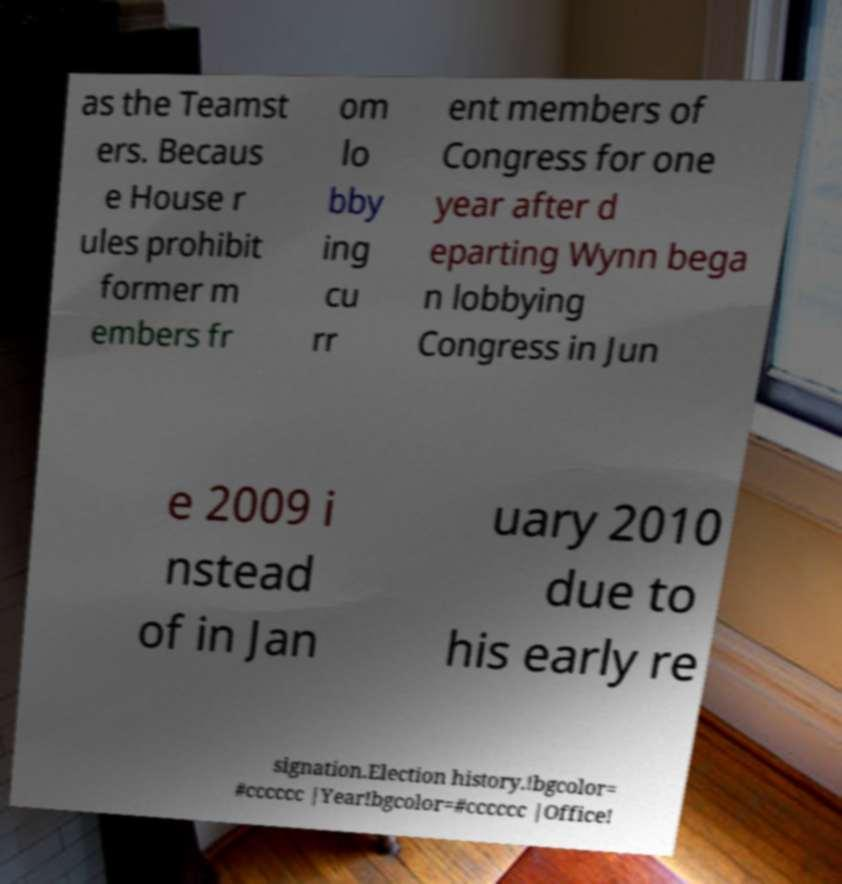There's text embedded in this image that I need extracted. Can you transcribe it verbatim? as the Teamst ers. Becaus e House r ules prohibit former m embers fr om lo bby ing cu rr ent members of Congress for one year after d eparting Wynn bega n lobbying Congress in Jun e 2009 i nstead of in Jan uary 2010 due to his early re signation.Election history.!bgcolor= #cccccc |Year!bgcolor=#cccccc |Office! 